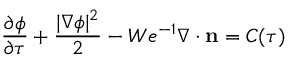Convert formula to latex. <formula><loc_0><loc_0><loc_500><loc_500>\frac { \partial \phi } { \partial \tau } + \frac { | \nabla \phi | ^ { 2 } } { 2 } - W e ^ { - 1 } \nabla \cdot n = C ( \tau )</formula> 